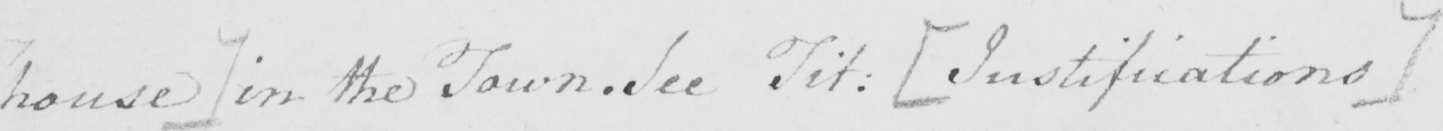Please transcribe the handwritten text in this image. house ]  in the Town . See Tit :  [ Justifications ] 